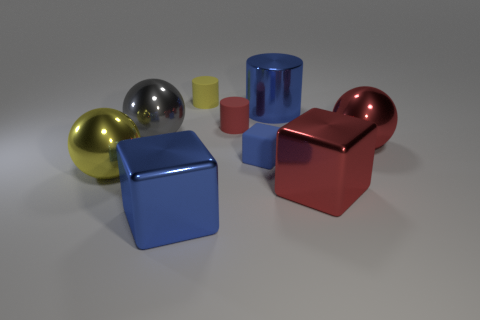Add 1 blue blocks. How many objects exist? 10 Subtract all spheres. How many objects are left? 6 Subtract 1 yellow cylinders. How many objects are left? 8 Subtract all small yellow matte cylinders. Subtract all large things. How many objects are left? 2 Add 7 large yellow metal balls. How many large yellow metal balls are left? 8 Add 8 large blue metallic objects. How many large blue metallic objects exist? 10 